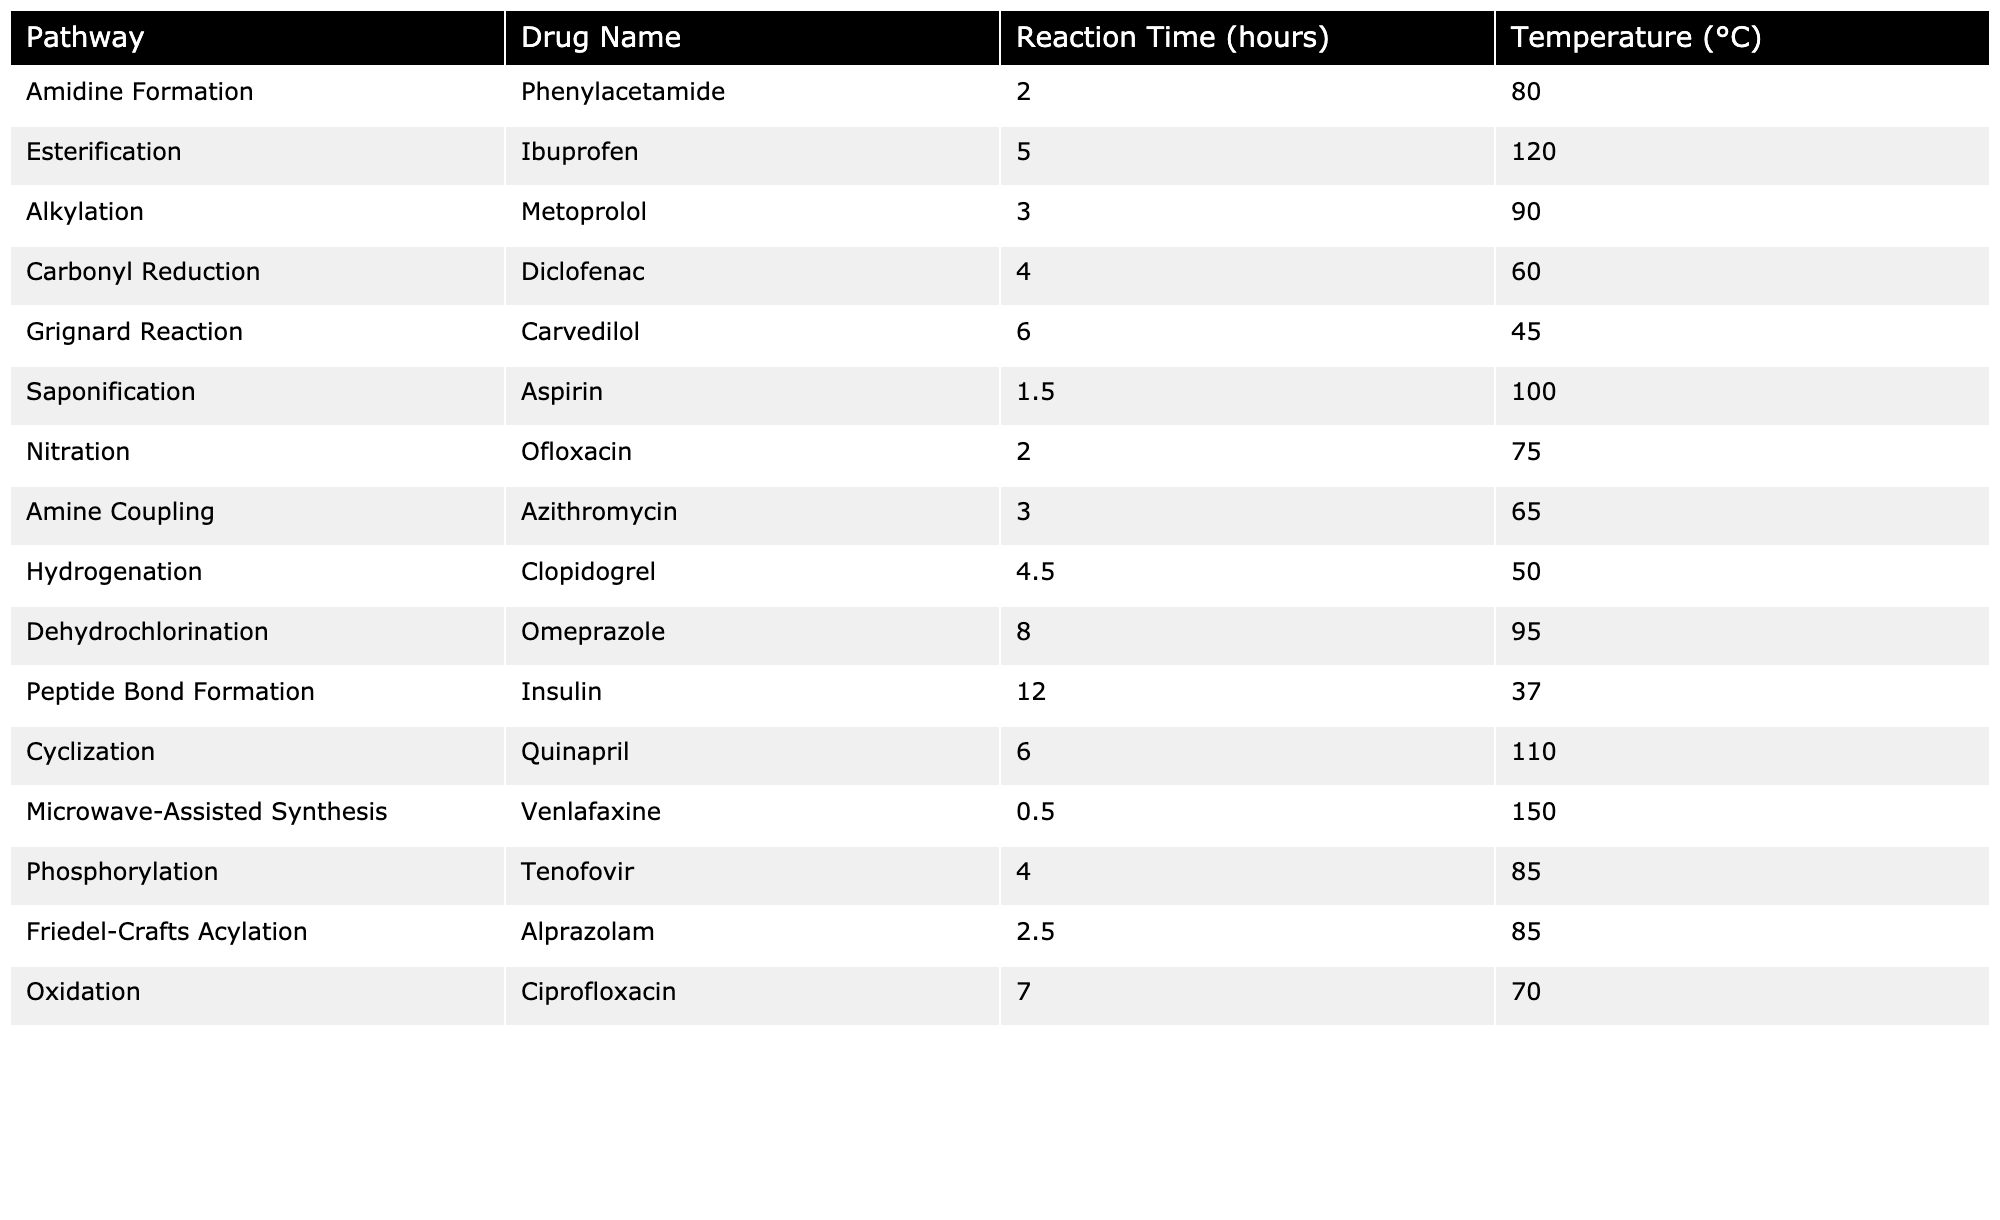What is the reaction time for the synthesis of Venlafaxine? The table shows that the reaction time for Venlafaxine, which is synthesized through Microwave-Assisted Synthesis, is 0.5 hours.
Answer: 0.5 hours Which drug synthesis pathway has the highest reaction temperature? Reviewing the table indicates that the pathway with the highest reaction temperature is Microwave-Assisted Synthesis of Venlafaxine at 150 °C.
Answer: Microwave-Assisted Synthesis What is the average reaction time across all pathways? To find the average, we sum the reaction times (2 + 5 + 3 + 4 + 6 + 1.5 + 2 + 3 + 4.5 + 8 + 12 + 6 + 0.5 + 4 + 2.5 + 7 = 60) and divide by the total number of pathways (16), which gives an average of 60/16 = 3.75 hours.
Answer: 3.75 hours Is the reaction time for Carbonyl Reduction less than 5 hours? The table states that the reaction time for Carbonyl Reduction is 4 hours, which is indeed less than 5 hours, making the statement true.
Answer: Yes Which drug requires the longest synthesis time and what is that time? By examining the reaction times in the table, Peptide Bond Formation for Insulin has the longest synthesis time of 12 hours.
Answer: Insulin, 12 hours What is the temperature difference between the pathways with the highest and lowest reaction temperature? The highest temperature is for Microwave-Assisted Synthesis at 150 °C, and the lowest is for the Peptide Bond Formation at 37 °C. The difference is 150 - 37 = 113 °C.
Answer: 113 °C How many synthesis pathways have a reaction time of less than 3 hours? Checking the table, there are 3 pathways with a reaction time under 3 hours: Saponification (1.5 hours) and Microwave-Assisted Synthesis (0.5 hours).
Answer: 2 pathways Which drug has a reaction time that's exactly 6 hours? According to the table, Carvedilol's synthesis through the Grignard Reaction and Quinapril's synthesis through Cyclization both have a reaction time of 6 hours.
Answer: Carvedilol and Quinapril What is the total reaction time for all the pathways that operate at a temperature of 85 °C? The pathways at 85 °C are Phosphorylation (4 hours) and Friedel-Crafts Acylation (2.5 hours). Therefore, the total time is 4 + 2.5 = 6.5 hours.
Answer: 6.5 hours Is there any drug synthesis pathway that takes longer than 10 hours? The table shows that only the Peptide Bond Formation for Insulin takes longer than 10 hours at 12 hours. Thus, the statement is true.
Answer: Yes 